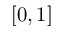<formula> <loc_0><loc_0><loc_500><loc_500>[ 0 , 1 ]</formula> 